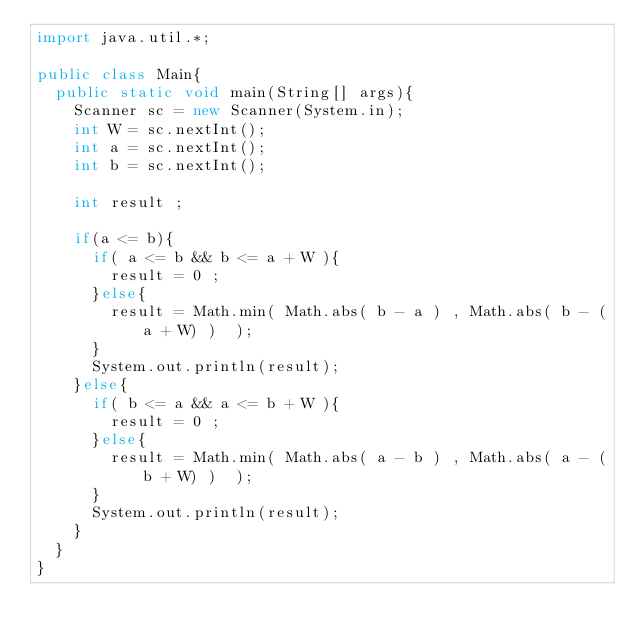Convert code to text. <code><loc_0><loc_0><loc_500><loc_500><_Java_>import java.util.*;

public class Main{
  public static void main(String[] args){
    Scanner sc = new Scanner(System.in);
    int W = sc.nextInt();
    int a = sc.nextInt();
    int b = sc.nextInt();

    int result ;

    if(a <= b){
      if( a <= b && b <= a + W ){
        result = 0 ;
      }else{
        result = Math.min( Math.abs( b - a ) , Math.abs( b - (a + W) )  );
      }
      System.out.println(result);
    }else{
      if( b <= a && a <= b + W ){
        result = 0 ;
      }else{
        result = Math.min( Math.abs( a - b ) , Math.abs( a - (b + W) )  );
      }
      System.out.println(result);
    }
  }
}
</code> 